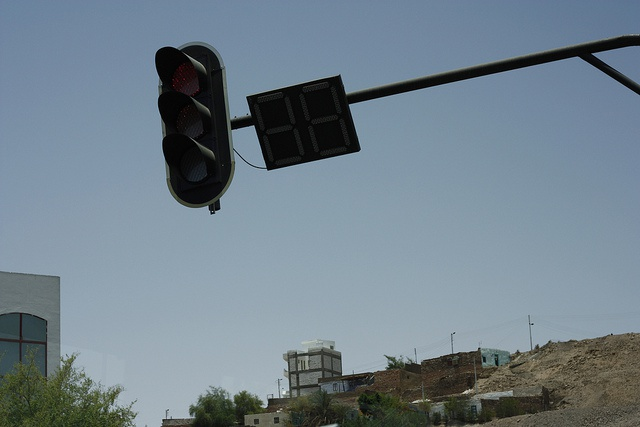Describe the objects in this image and their specific colors. I can see a traffic light in gray, black, and maroon tones in this image. 